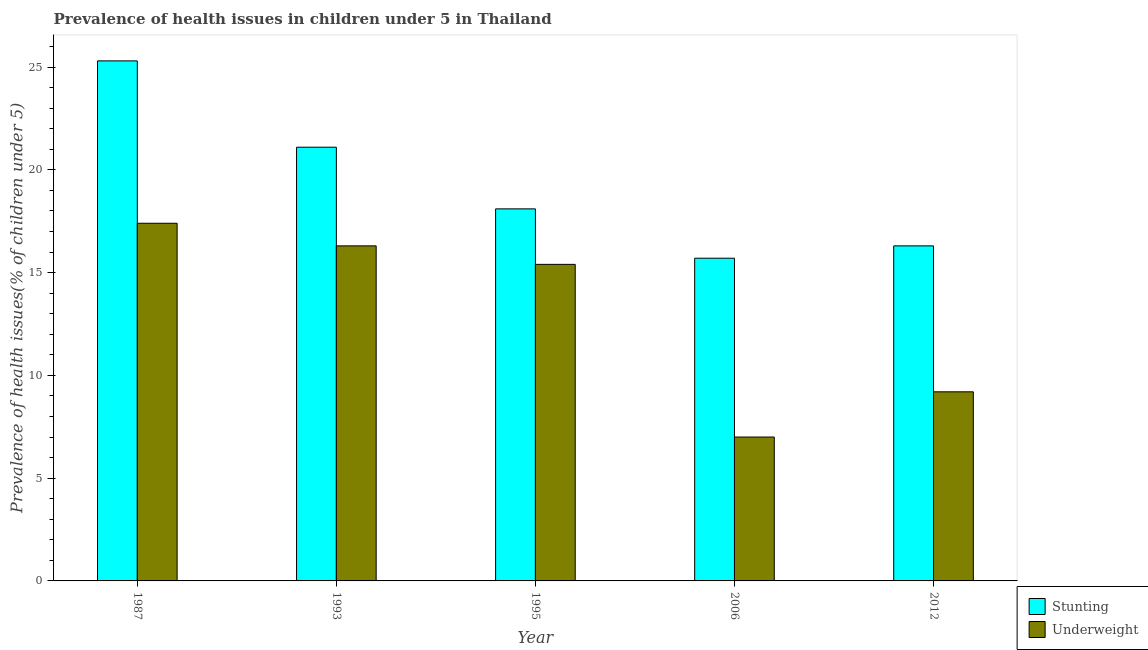How many different coloured bars are there?
Provide a succinct answer. 2. How many groups of bars are there?
Ensure brevity in your answer.  5. Are the number of bars per tick equal to the number of legend labels?
Offer a terse response. Yes. Are the number of bars on each tick of the X-axis equal?
Keep it short and to the point. Yes. How many bars are there on the 1st tick from the right?
Provide a short and direct response. 2. What is the label of the 5th group of bars from the left?
Ensure brevity in your answer.  2012. In how many cases, is the number of bars for a given year not equal to the number of legend labels?
Ensure brevity in your answer.  0. What is the percentage of underweight children in 2012?
Give a very brief answer. 9.2. Across all years, what is the maximum percentage of stunted children?
Offer a very short reply. 25.3. Across all years, what is the minimum percentage of stunted children?
Keep it short and to the point. 15.7. In which year was the percentage of underweight children maximum?
Your answer should be compact. 1987. What is the total percentage of underweight children in the graph?
Your answer should be very brief. 65.3. What is the difference between the percentage of underweight children in 2006 and that in 2012?
Your response must be concise. -2.2. What is the difference between the percentage of stunted children in 2006 and the percentage of underweight children in 1993?
Keep it short and to the point. -5.4. What is the average percentage of stunted children per year?
Your response must be concise. 19.3. What is the ratio of the percentage of stunted children in 1993 to that in 2012?
Offer a very short reply. 1.29. What is the difference between the highest and the second highest percentage of stunted children?
Provide a succinct answer. 4.2. What is the difference between the highest and the lowest percentage of stunted children?
Offer a terse response. 9.6. In how many years, is the percentage of underweight children greater than the average percentage of underweight children taken over all years?
Provide a succinct answer. 3. What does the 1st bar from the left in 2012 represents?
Keep it short and to the point. Stunting. What does the 2nd bar from the right in 1993 represents?
Keep it short and to the point. Stunting. How many bars are there?
Provide a short and direct response. 10. Are all the bars in the graph horizontal?
Offer a very short reply. No. Does the graph contain any zero values?
Keep it short and to the point. No. Does the graph contain grids?
Provide a succinct answer. No. How are the legend labels stacked?
Ensure brevity in your answer.  Vertical. What is the title of the graph?
Provide a short and direct response. Prevalence of health issues in children under 5 in Thailand. What is the label or title of the Y-axis?
Offer a very short reply. Prevalence of health issues(% of children under 5). What is the Prevalence of health issues(% of children under 5) of Stunting in 1987?
Keep it short and to the point. 25.3. What is the Prevalence of health issues(% of children under 5) of Underweight in 1987?
Provide a succinct answer. 17.4. What is the Prevalence of health issues(% of children under 5) of Stunting in 1993?
Keep it short and to the point. 21.1. What is the Prevalence of health issues(% of children under 5) in Underweight in 1993?
Offer a terse response. 16.3. What is the Prevalence of health issues(% of children under 5) in Stunting in 1995?
Your response must be concise. 18.1. What is the Prevalence of health issues(% of children under 5) of Underweight in 1995?
Give a very brief answer. 15.4. What is the Prevalence of health issues(% of children under 5) of Stunting in 2006?
Your response must be concise. 15.7. What is the Prevalence of health issues(% of children under 5) of Underweight in 2006?
Your answer should be compact. 7. What is the Prevalence of health issues(% of children under 5) in Stunting in 2012?
Keep it short and to the point. 16.3. What is the Prevalence of health issues(% of children under 5) of Underweight in 2012?
Make the answer very short. 9.2. Across all years, what is the maximum Prevalence of health issues(% of children under 5) in Stunting?
Your response must be concise. 25.3. Across all years, what is the maximum Prevalence of health issues(% of children under 5) in Underweight?
Make the answer very short. 17.4. Across all years, what is the minimum Prevalence of health issues(% of children under 5) of Stunting?
Provide a short and direct response. 15.7. What is the total Prevalence of health issues(% of children under 5) in Stunting in the graph?
Offer a very short reply. 96.5. What is the total Prevalence of health issues(% of children under 5) of Underweight in the graph?
Offer a very short reply. 65.3. What is the difference between the Prevalence of health issues(% of children under 5) of Stunting in 1987 and that in 1993?
Ensure brevity in your answer.  4.2. What is the difference between the Prevalence of health issues(% of children under 5) of Underweight in 1987 and that in 1993?
Ensure brevity in your answer.  1.1. What is the difference between the Prevalence of health issues(% of children under 5) in Underweight in 1987 and that in 1995?
Your answer should be compact. 2. What is the difference between the Prevalence of health issues(% of children under 5) in Stunting in 1993 and that in 2006?
Keep it short and to the point. 5.4. What is the difference between the Prevalence of health issues(% of children under 5) of Stunting in 1993 and that in 2012?
Give a very brief answer. 4.8. What is the difference between the Prevalence of health issues(% of children under 5) of Underweight in 1993 and that in 2012?
Provide a short and direct response. 7.1. What is the difference between the Prevalence of health issues(% of children under 5) of Stunting in 1995 and that in 2006?
Keep it short and to the point. 2.4. What is the difference between the Prevalence of health issues(% of children under 5) in Underweight in 1995 and that in 2006?
Make the answer very short. 8.4. What is the difference between the Prevalence of health issues(% of children under 5) of Stunting in 2006 and that in 2012?
Your answer should be compact. -0.6. What is the difference between the Prevalence of health issues(% of children under 5) of Underweight in 2006 and that in 2012?
Keep it short and to the point. -2.2. What is the difference between the Prevalence of health issues(% of children under 5) of Stunting in 1987 and the Prevalence of health issues(% of children under 5) of Underweight in 2006?
Your response must be concise. 18.3. What is the difference between the Prevalence of health issues(% of children under 5) in Stunting in 1993 and the Prevalence of health issues(% of children under 5) in Underweight in 2012?
Make the answer very short. 11.9. What is the difference between the Prevalence of health issues(% of children under 5) in Stunting in 1995 and the Prevalence of health issues(% of children under 5) in Underweight in 2006?
Provide a short and direct response. 11.1. What is the difference between the Prevalence of health issues(% of children under 5) of Stunting in 1995 and the Prevalence of health issues(% of children under 5) of Underweight in 2012?
Offer a very short reply. 8.9. What is the difference between the Prevalence of health issues(% of children under 5) of Stunting in 2006 and the Prevalence of health issues(% of children under 5) of Underweight in 2012?
Ensure brevity in your answer.  6.5. What is the average Prevalence of health issues(% of children under 5) of Stunting per year?
Provide a succinct answer. 19.3. What is the average Prevalence of health issues(% of children under 5) of Underweight per year?
Provide a short and direct response. 13.06. In the year 1987, what is the difference between the Prevalence of health issues(% of children under 5) of Stunting and Prevalence of health issues(% of children under 5) of Underweight?
Offer a very short reply. 7.9. In the year 2006, what is the difference between the Prevalence of health issues(% of children under 5) of Stunting and Prevalence of health issues(% of children under 5) of Underweight?
Offer a very short reply. 8.7. What is the ratio of the Prevalence of health issues(% of children under 5) of Stunting in 1987 to that in 1993?
Your answer should be very brief. 1.2. What is the ratio of the Prevalence of health issues(% of children under 5) in Underweight in 1987 to that in 1993?
Your answer should be compact. 1.07. What is the ratio of the Prevalence of health issues(% of children under 5) of Stunting in 1987 to that in 1995?
Provide a succinct answer. 1.4. What is the ratio of the Prevalence of health issues(% of children under 5) in Underweight in 1987 to that in 1995?
Keep it short and to the point. 1.13. What is the ratio of the Prevalence of health issues(% of children under 5) of Stunting in 1987 to that in 2006?
Ensure brevity in your answer.  1.61. What is the ratio of the Prevalence of health issues(% of children under 5) in Underweight in 1987 to that in 2006?
Your answer should be very brief. 2.49. What is the ratio of the Prevalence of health issues(% of children under 5) of Stunting in 1987 to that in 2012?
Offer a very short reply. 1.55. What is the ratio of the Prevalence of health issues(% of children under 5) of Underweight in 1987 to that in 2012?
Your answer should be compact. 1.89. What is the ratio of the Prevalence of health issues(% of children under 5) in Stunting in 1993 to that in 1995?
Your response must be concise. 1.17. What is the ratio of the Prevalence of health issues(% of children under 5) in Underweight in 1993 to that in 1995?
Your answer should be very brief. 1.06. What is the ratio of the Prevalence of health issues(% of children under 5) in Stunting in 1993 to that in 2006?
Make the answer very short. 1.34. What is the ratio of the Prevalence of health issues(% of children under 5) of Underweight in 1993 to that in 2006?
Your answer should be very brief. 2.33. What is the ratio of the Prevalence of health issues(% of children under 5) of Stunting in 1993 to that in 2012?
Your answer should be very brief. 1.29. What is the ratio of the Prevalence of health issues(% of children under 5) of Underweight in 1993 to that in 2012?
Make the answer very short. 1.77. What is the ratio of the Prevalence of health issues(% of children under 5) of Stunting in 1995 to that in 2006?
Your answer should be very brief. 1.15. What is the ratio of the Prevalence of health issues(% of children under 5) of Underweight in 1995 to that in 2006?
Offer a very short reply. 2.2. What is the ratio of the Prevalence of health issues(% of children under 5) in Stunting in 1995 to that in 2012?
Keep it short and to the point. 1.11. What is the ratio of the Prevalence of health issues(% of children under 5) of Underweight in 1995 to that in 2012?
Offer a terse response. 1.67. What is the ratio of the Prevalence of health issues(% of children under 5) of Stunting in 2006 to that in 2012?
Make the answer very short. 0.96. What is the ratio of the Prevalence of health issues(% of children under 5) of Underweight in 2006 to that in 2012?
Give a very brief answer. 0.76. What is the difference between the highest and the second highest Prevalence of health issues(% of children under 5) in Underweight?
Your answer should be compact. 1.1. What is the difference between the highest and the lowest Prevalence of health issues(% of children under 5) of Stunting?
Your answer should be very brief. 9.6. What is the difference between the highest and the lowest Prevalence of health issues(% of children under 5) of Underweight?
Ensure brevity in your answer.  10.4. 